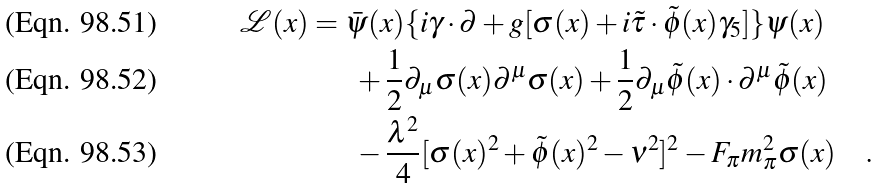Convert formula to latex. <formula><loc_0><loc_0><loc_500><loc_500>\mathcal { L } ( x ) & = \bar { \psi } ( x ) \{ i \gamma \cdot \partial + g [ \sigma ( x ) + i { \tilde { \tau } } \cdot { \tilde { \phi } } ( x ) \gamma _ { 5 } ] \} \psi ( x ) \\ & \quad \ \ + \frac { 1 } { 2 } \partial _ { \mu } \sigma ( x ) \partial ^ { \mu } \sigma ( x ) + \frac { 1 } { 2 } \partial _ { \mu } { \tilde { \phi } } ( x ) \cdot \partial ^ { \mu } { \tilde { \phi } } ( x ) \\ & \quad \ \ - \frac { \lambda ^ { 2 } } { 4 } [ \sigma ( x ) ^ { 2 } + { \tilde { \phi } } ( x ) ^ { 2 } - \nu ^ { 2 } ] ^ { 2 } - F _ { \pi } m _ { \pi } ^ { 2 } \sigma ( x ) \quad .</formula> 